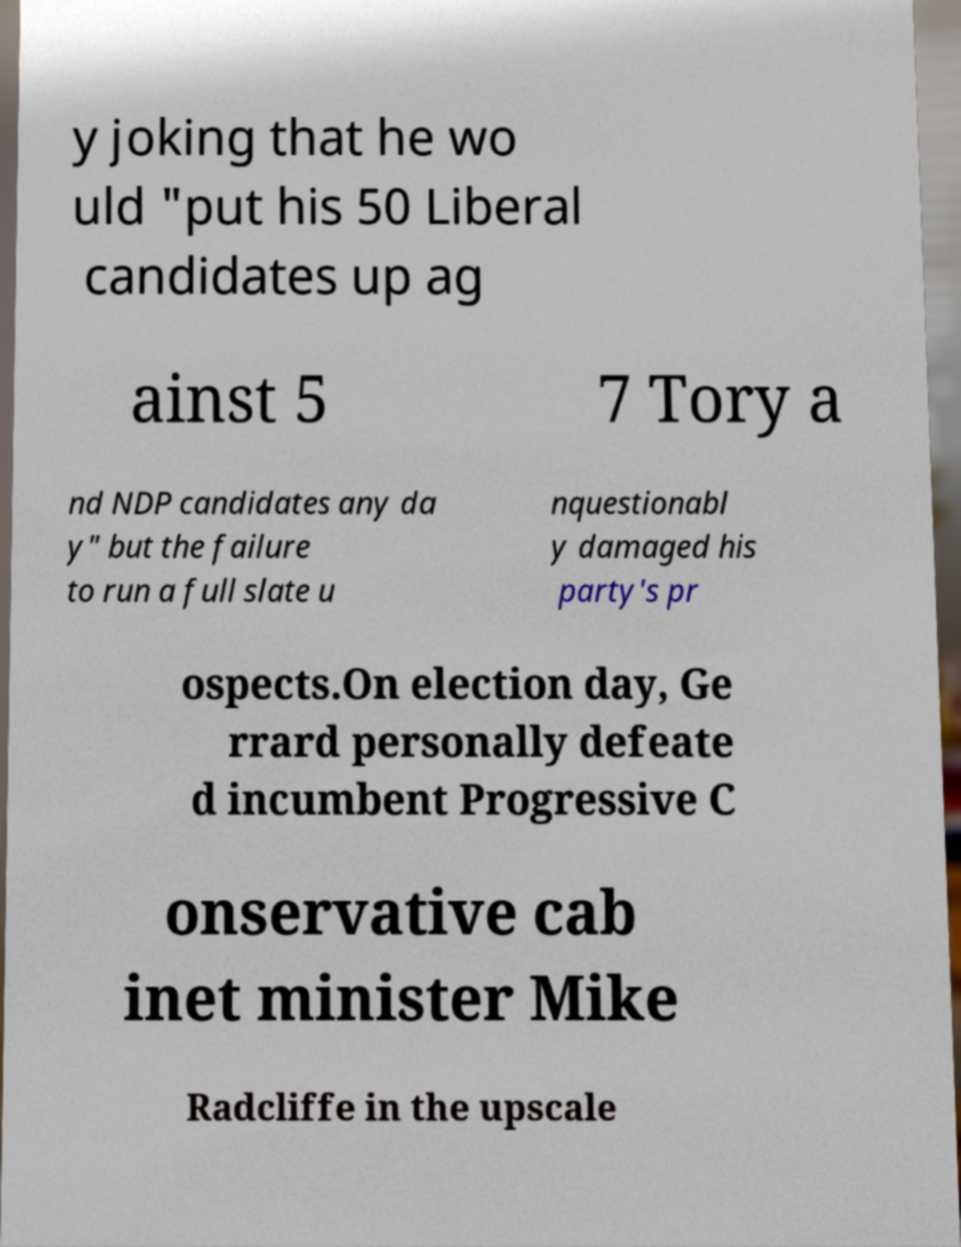Please read and relay the text visible in this image. What does it say? y joking that he wo uld "put his 50 Liberal candidates up ag ainst 5 7 Tory a nd NDP candidates any da y" but the failure to run a full slate u nquestionabl y damaged his party's pr ospects.On election day, Ge rrard personally defeate d incumbent Progressive C onservative cab inet minister Mike Radcliffe in the upscale 